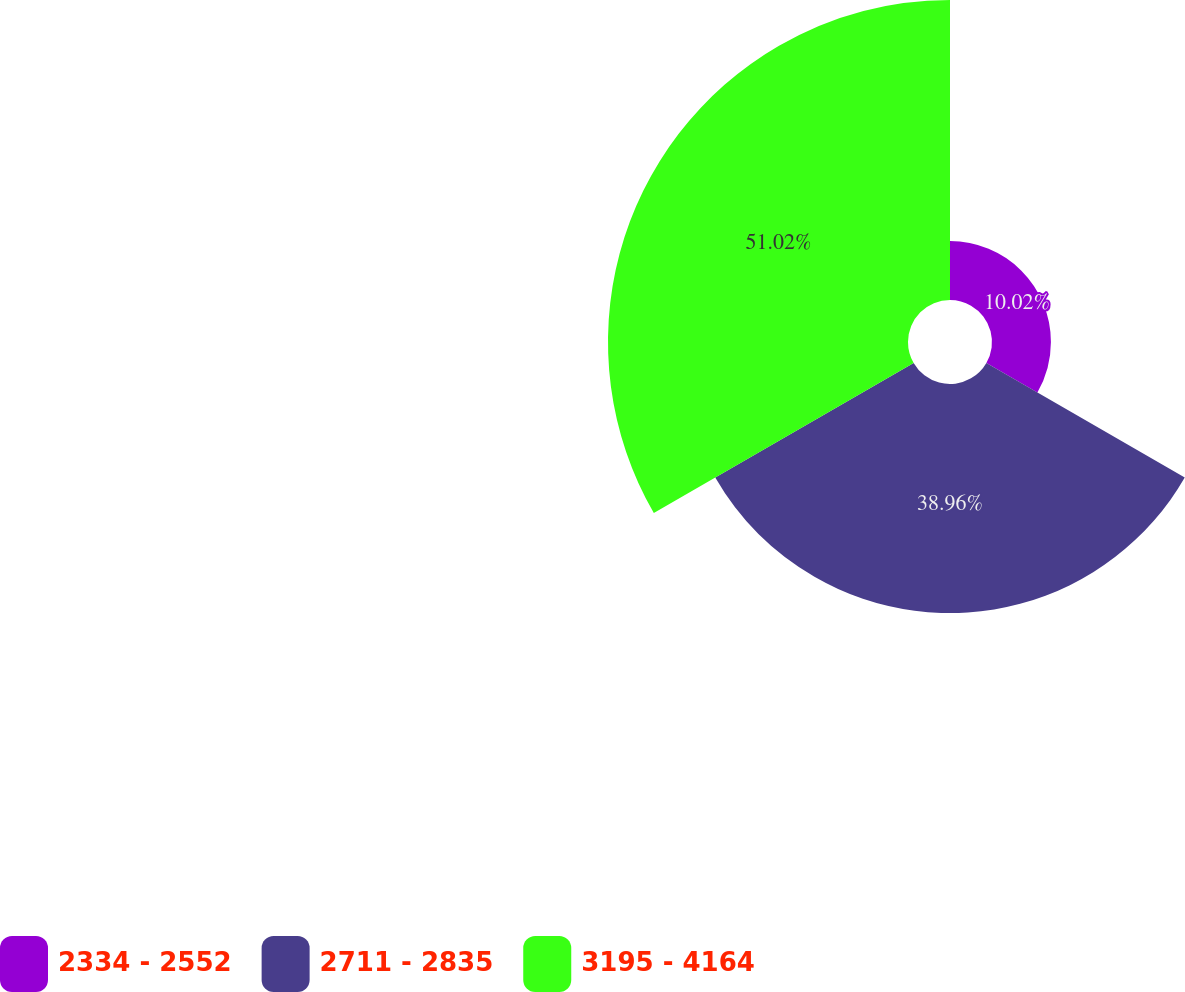Convert chart. <chart><loc_0><loc_0><loc_500><loc_500><pie_chart><fcel>2334 - 2552<fcel>2711 - 2835<fcel>3195 - 4164<nl><fcel>10.02%<fcel>38.96%<fcel>51.02%<nl></chart> 